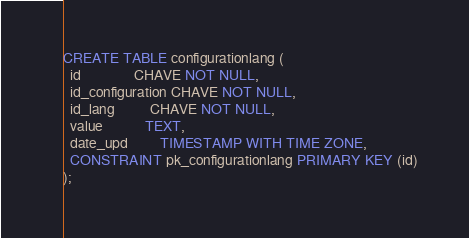Convert code to text. <code><loc_0><loc_0><loc_500><loc_500><_SQL_>CREATE TABLE configurationlang (
  id               CHAVE NOT NULL,
  id_configuration CHAVE NOT NULL,
  id_lang          CHAVE NOT NULL,
  value            TEXT,
  date_upd         TIMESTAMP WITH TIME ZONE,
  CONSTRAINT pk_configurationlang PRIMARY KEY (id)
);</code> 